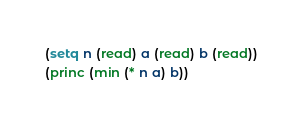<code> <loc_0><loc_0><loc_500><loc_500><_Lisp_>(setq n (read) a (read) b (read))
(princ (min (* n a) b))</code> 